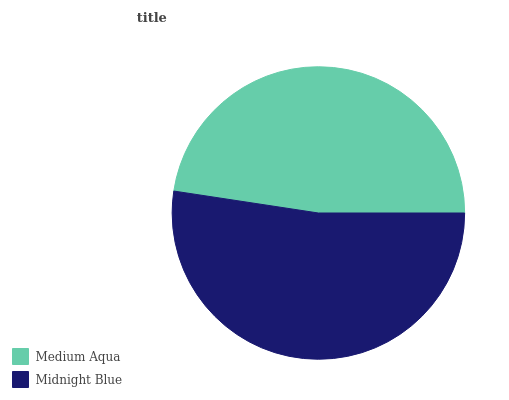Is Medium Aqua the minimum?
Answer yes or no. Yes. Is Midnight Blue the maximum?
Answer yes or no. Yes. Is Midnight Blue the minimum?
Answer yes or no. No. Is Midnight Blue greater than Medium Aqua?
Answer yes or no. Yes. Is Medium Aqua less than Midnight Blue?
Answer yes or no. Yes. Is Medium Aqua greater than Midnight Blue?
Answer yes or no. No. Is Midnight Blue less than Medium Aqua?
Answer yes or no. No. Is Midnight Blue the high median?
Answer yes or no. Yes. Is Medium Aqua the low median?
Answer yes or no. Yes. Is Medium Aqua the high median?
Answer yes or no. No. Is Midnight Blue the low median?
Answer yes or no. No. 